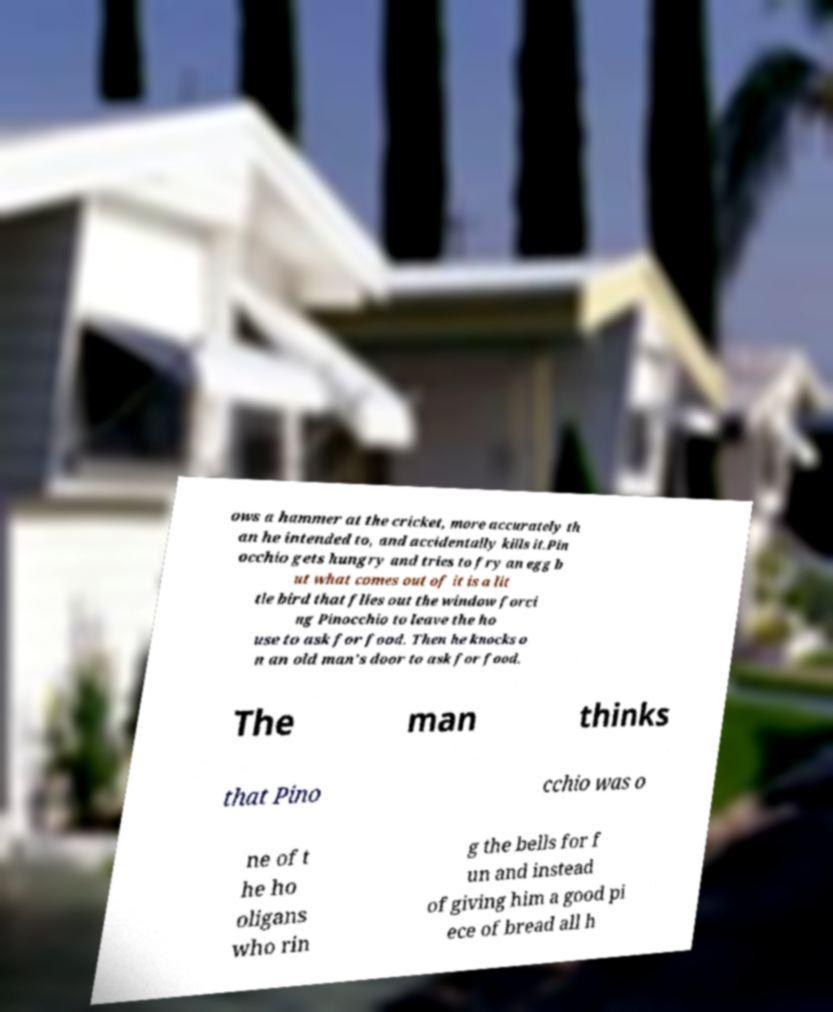I need the written content from this picture converted into text. Can you do that? ows a hammer at the cricket, more accurately th an he intended to, and accidentally kills it.Pin occhio gets hungry and tries to fry an egg b ut what comes out of it is a lit tle bird that flies out the window forci ng Pinocchio to leave the ho use to ask for food. Then he knocks o n an old man's door to ask for food. The man thinks that Pino cchio was o ne of t he ho oligans who rin g the bells for f un and instead of giving him a good pi ece of bread all h 